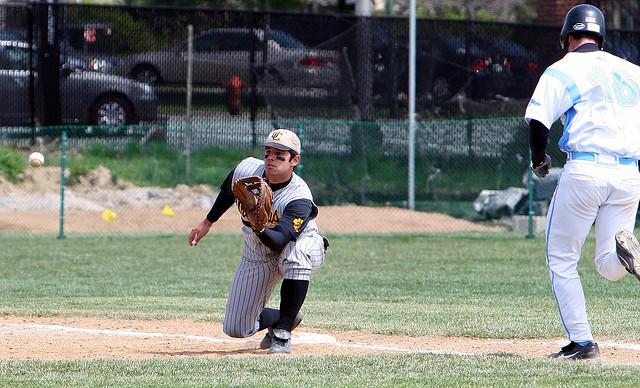What color are the two flags?
Concise answer only. Yellow. What game are they playing?
Short answer required. Baseball. What is under the man's eyes?
Give a very brief answer. Black. 